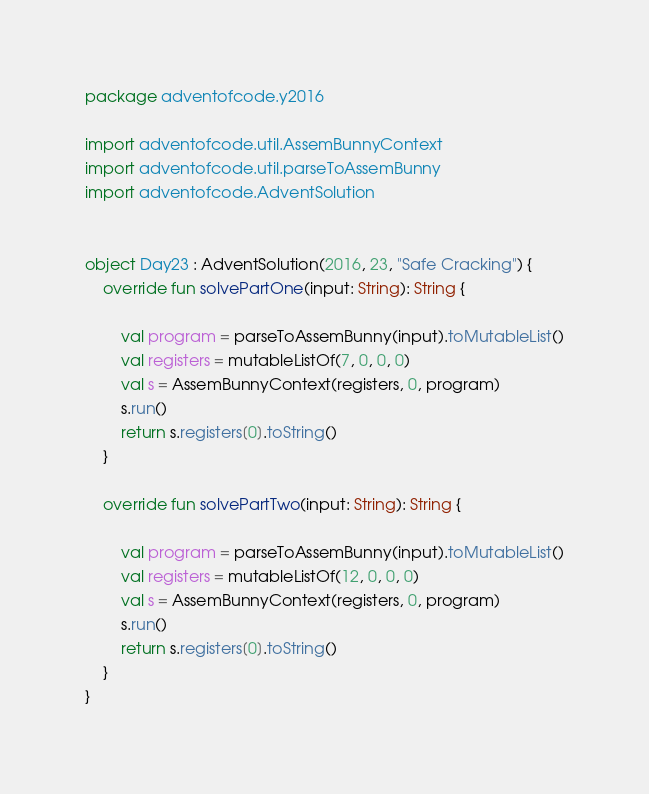<code> <loc_0><loc_0><loc_500><loc_500><_Kotlin_>package adventofcode.y2016

import adventofcode.util.AssemBunnyContext
import adventofcode.util.parseToAssemBunny
import adventofcode.AdventSolution


object Day23 : AdventSolution(2016, 23, "Safe Cracking") {
	override fun solvePartOne(input: String): String {

		val program = parseToAssemBunny(input).toMutableList()
		val registers = mutableListOf(7, 0, 0, 0)
		val s = AssemBunnyContext(registers, 0, program)
		s.run()
		return s.registers[0].toString()
	}

	override fun solvePartTwo(input: String): String {

		val program = parseToAssemBunny(input).toMutableList()
		val registers = mutableListOf(12, 0, 0, 0)
		val s = AssemBunnyContext(registers, 0, program)
		s.run()
		return s.registers[0].toString()
	}
}
</code> 